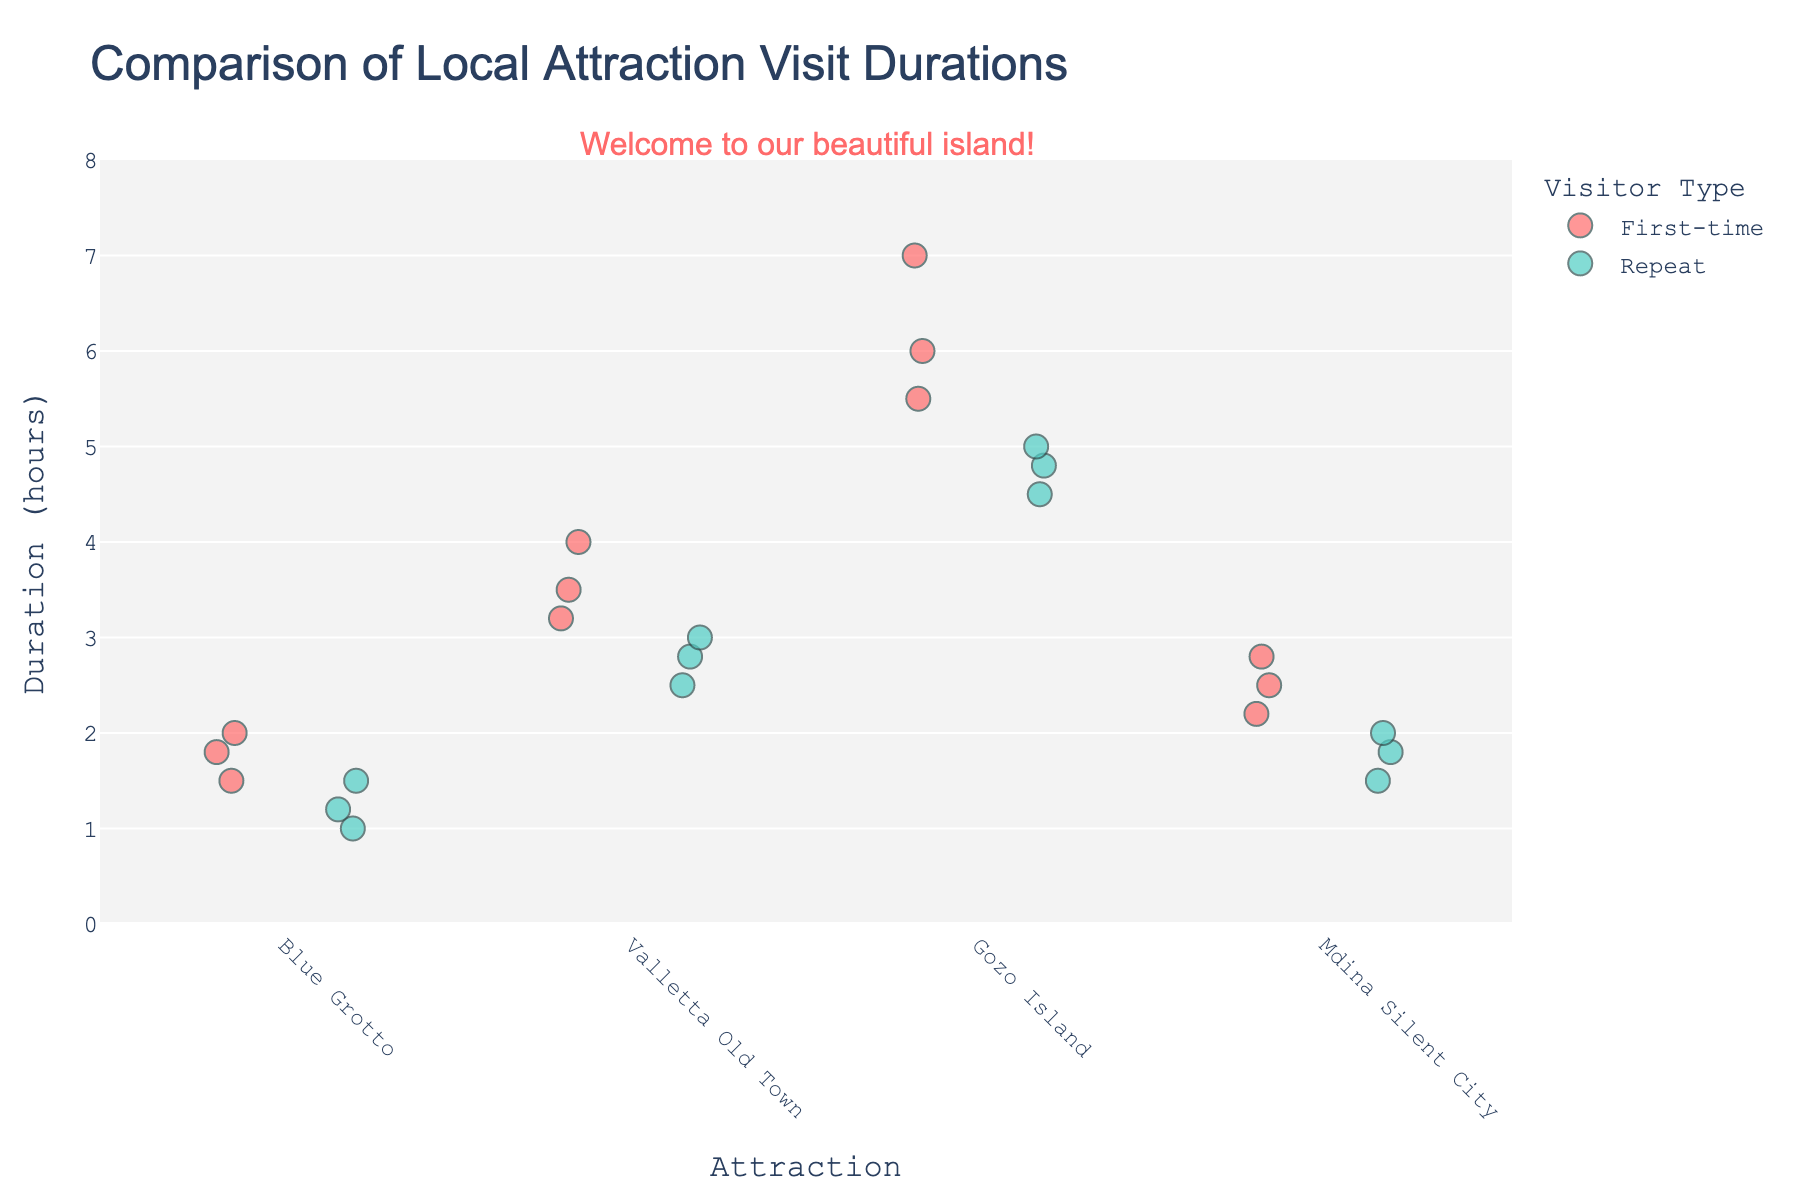What's the title of the plot? The title is located at the top center of the plot and provides an overview of what the visualization is about.
Answer: Comparison of Local Attraction Visit Durations What's the average visit duration for First-time visitors to the Blue Grotto? There are 3 data points for First-time visitors to the Blue Grotto: 1.5, 2.0, and 1.8 hours. The average is calculated as (1.5 + 2.0 + 1.8) / 3 = 1.77 hours.
Answer: 1.77 hours Which visitor type spends more time on average at Valletta Old Town? Comparing the average durations: 
First-time visitors: (3.5 + 4.0 + 3.2) / 3 = 3.57 hours 
Repeat visitors: (2.5 + 3.0 + 2.8) / 3 = 2.77 hours 
First-time visitors spend more time on average at Valletta Old Town.
Answer: First-time What is the range of visit durations for Gozo Island for First-time visitors? The range is the difference between the maximum and minimum values. For First-time visitors to Gozo Island, the durations are 6.0, 5.5, and 7.0 hours. The range is 7.0 - 5.5 = 1.5 hours.
Answer: 1.5 hours How many data points are there for Repeat visitors to Mdina Silent City? Count the number of markers for Repeat visitors at Mdina Silent City along the x-axis. There are 3 data points: 1.8, 2.0, and 1.5 hours.
Answer: 3 Do First-time visitors or Repeat visitors have more variability in visit durations to the Blue Grotto? Variability can be inferred by looking at the spread of the data points. For the Blue Grotto:
First-time: Data points are more spread out (1.5 to 2.0)
Repeat: Data points are more closely packed (1.0 to 1.5)
First-time visitors exhibit more variability.
Answer: First-time What is the median visit duration for Repeat visitors at the Gozo Island? There are 3 data points for Repeat visitors to Gozo Island: 4.5, 5.0, and 4.8 hours. The median is the middle value when they are ordered: 4.5, 4.8, 5.0, so the median is 4.8 hours.
Answer: 4.8 hours Which attraction has the highest maximum visit duration for any visitor type? Identify the highest data point for each attraction:
Blue Grotto: 2.0 hours (First-time)
Valletta Old Town: 4.0 hours (First-time)
Gozo Island: 7.0 hours (First-time)
Mdina Silent City: 2.8 hours (First-time)
Gozo Island has the highest maximum visit duration of 7.0 hours.
Answer: Gozo Island What is the total visit duration of all Repeat visitors to Blue Grotto? Sum the durations for Repeat visitors at Blue Grotto: 1.2 + 1.0 + 1.5 = 3.7 hours.
Answer: 3.7 hours 